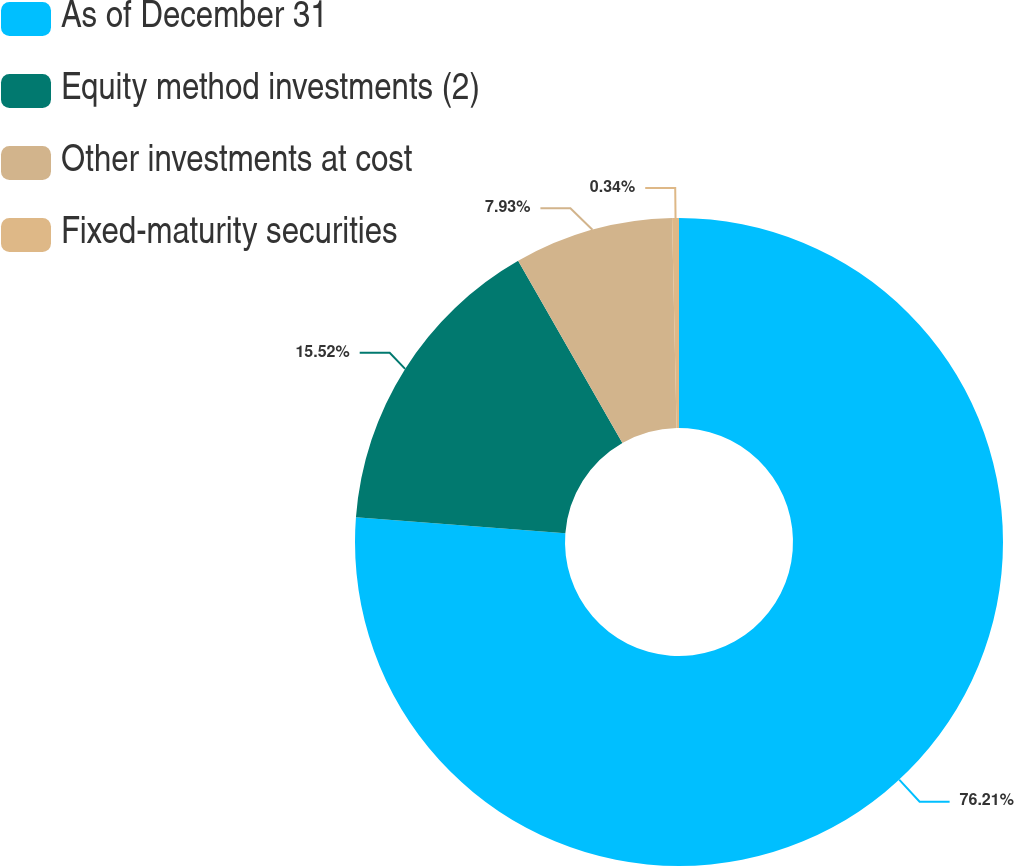Convert chart. <chart><loc_0><loc_0><loc_500><loc_500><pie_chart><fcel>As of December 31<fcel>Equity method investments (2)<fcel>Other investments at cost<fcel>Fixed-maturity securities<nl><fcel>76.22%<fcel>15.52%<fcel>7.93%<fcel>0.34%<nl></chart> 